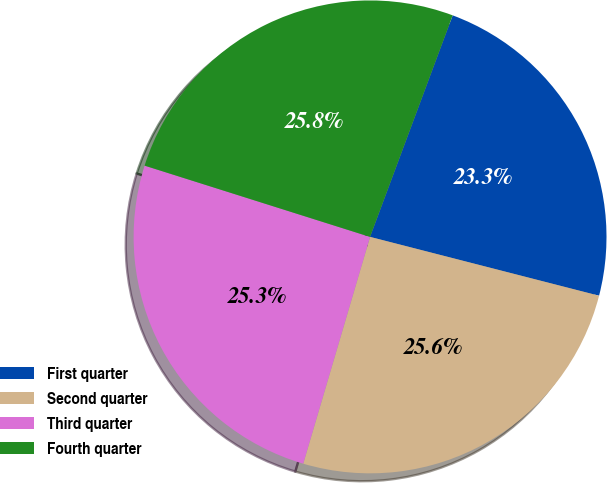Convert chart to OTSL. <chart><loc_0><loc_0><loc_500><loc_500><pie_chart><fcel>First quarter<fcel>Second quarter<fcel>Third quarter<fcel>Fourth quarter<nl><fcel>23.32%<fcel>25.56%<fcel>25.31%<fcel>25.81%<nl></chart> 